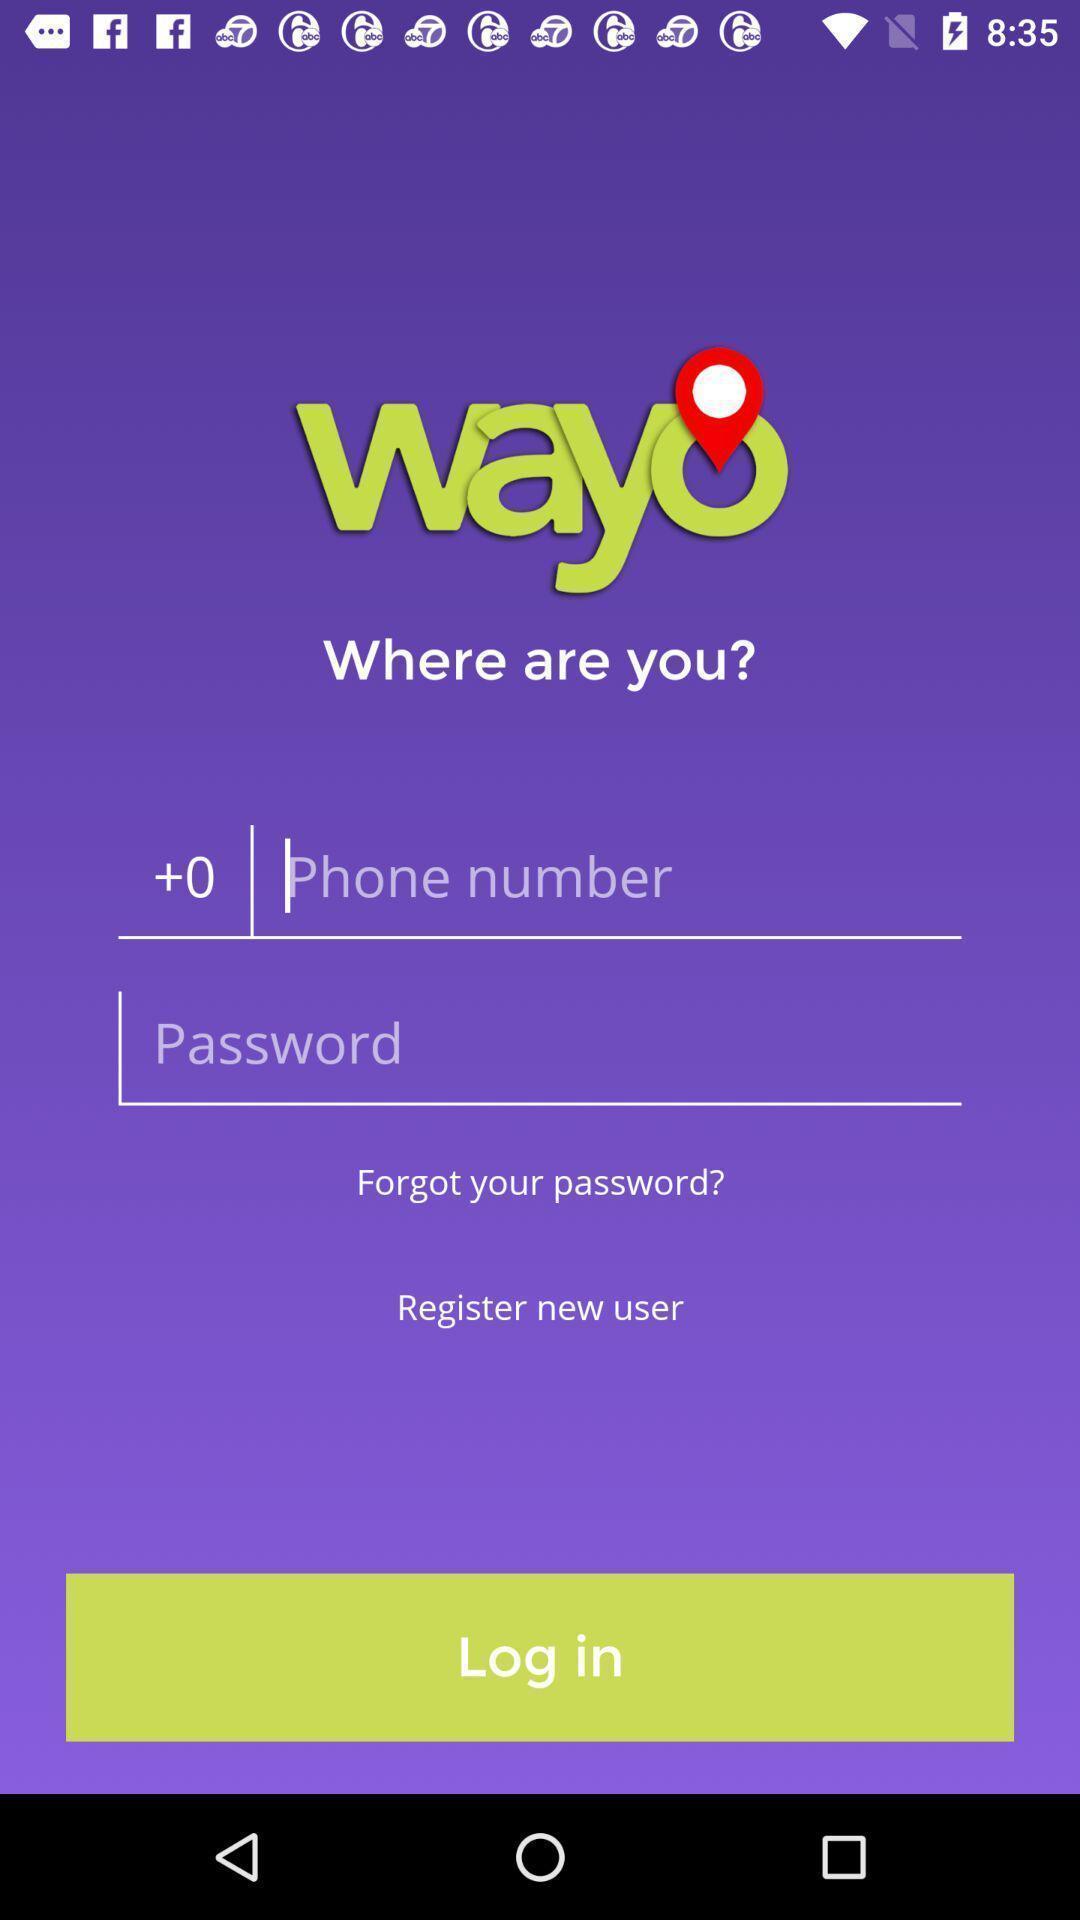Summarize the information in this screenshot. Login page. 